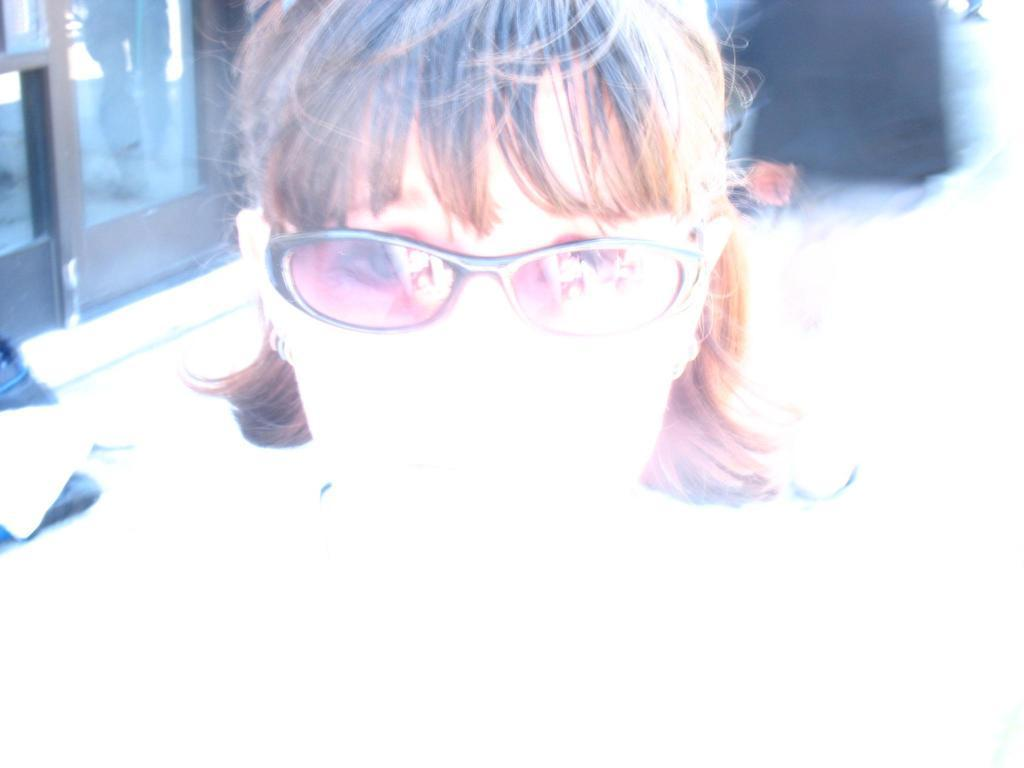Who or what is the main subject in the image? There is a person in the image. Can you describe the person's appearance? The person is wearing spectacles. What can be seen behind the person? There is a background in the image. What is located on the left side of the image? There are objects on the left side of the image. What material is visible in the image? There is glass visible in the image. What type of organization is the person affiliated with in the image? There is no information about the person's affiliation or any organization in the image. Can you describe the person's hands in the image? The hands of the person are not visible in the image. 